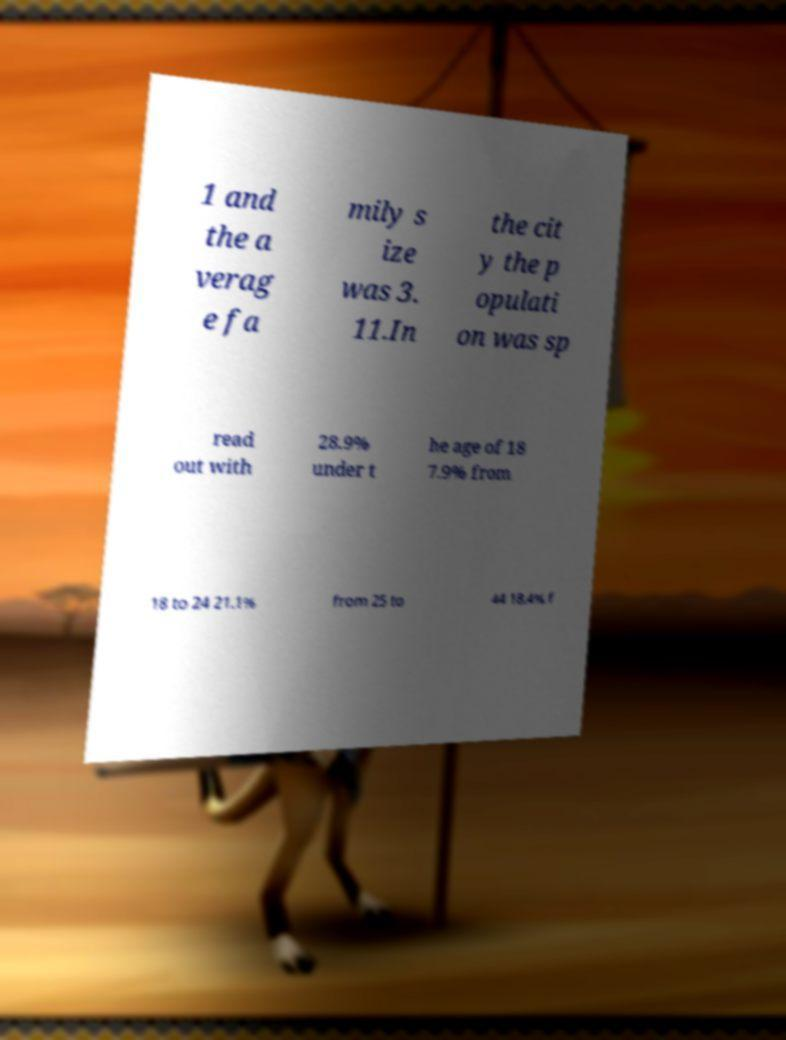Can you accurately transcribe the text from the provided image for me? 1 and the a verag e fa mily s ize was 3. 11.In the cit y the p opulati on was sp read out with 28.9% under t he age of 18 7.9% from 18 to 24 21.1% from 25 to 44 18.4% f 